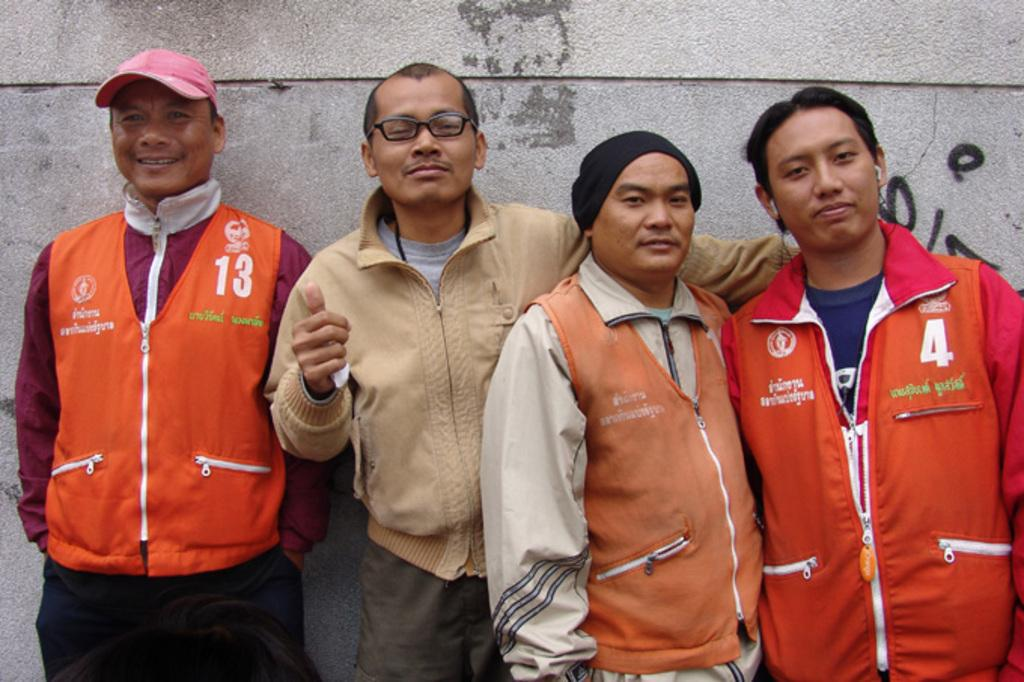<image>
Offer a succinct explanation of the picture presented. four people with one of them wearing a jacket that says '4' on it 